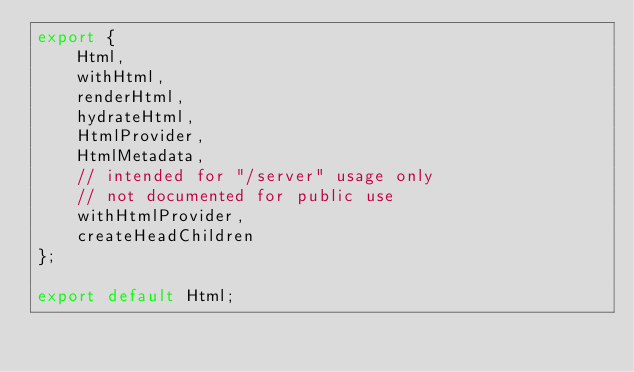<code> <loc_0><loc_0><loc_500><loc_500><_JavaScript_>export {
    Html,
    withHtml,
    renderHtml,
    hydrateHtml,
    HtmlProvider,
    HtmlMetadata,
    // intended for "/server" usage only
    // not documented for public use
    withHtmlProvider,
    createHeadChildren
};

export default Html;
</code> 